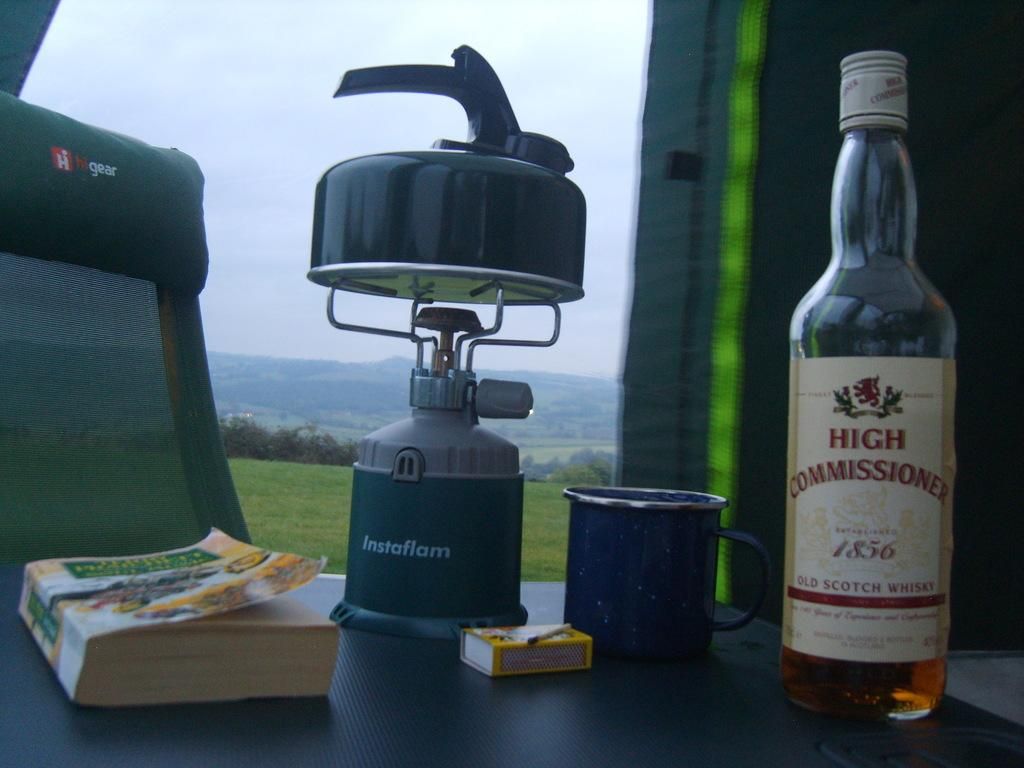Provide a one-sentence caption for the provided image. A tea kettle is sitting on top of an unlit Instaflam camping burner. 